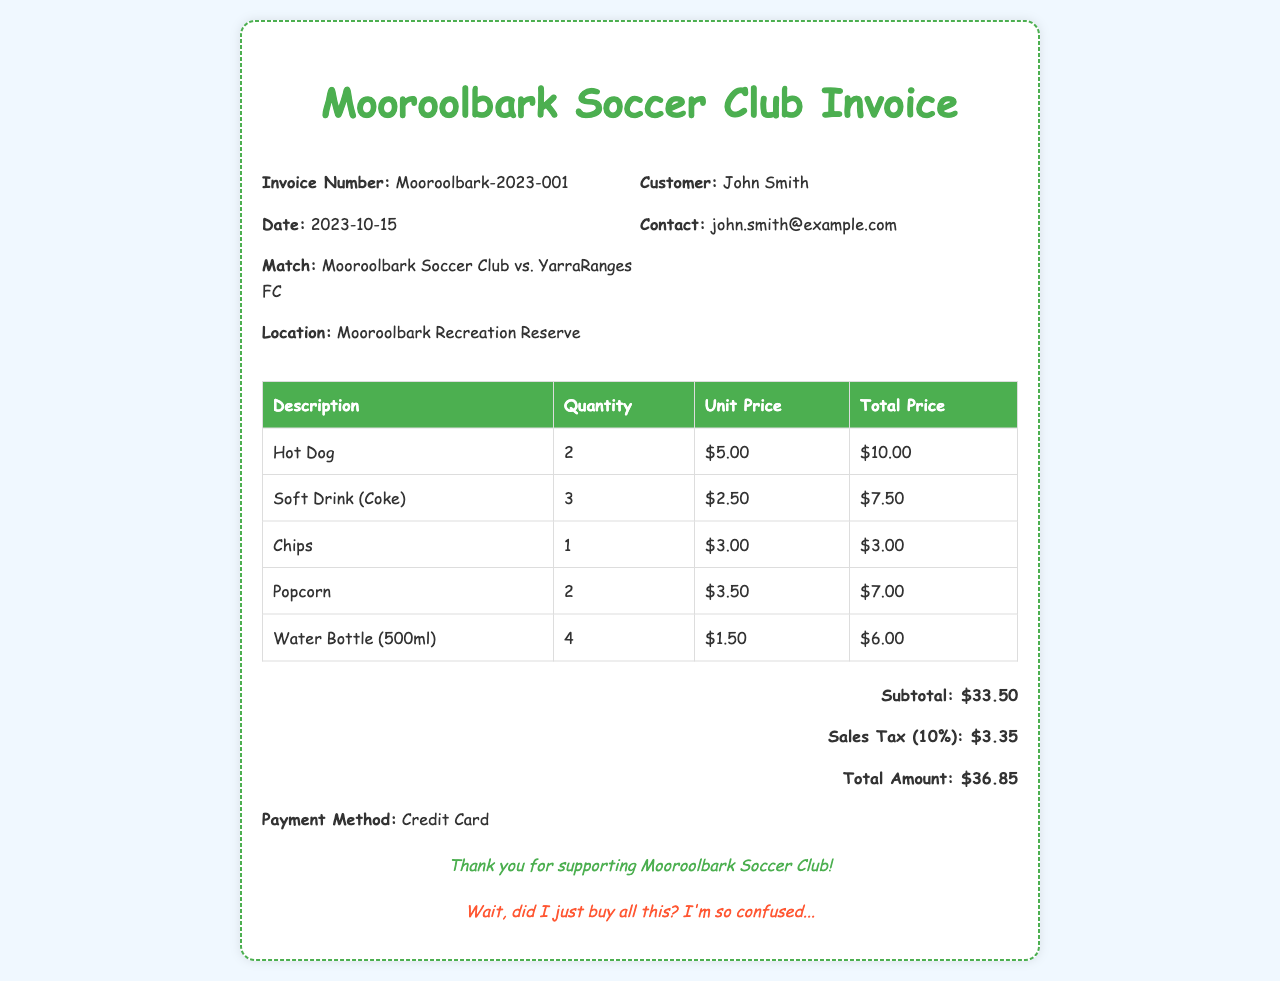What is the invoice number? The invoice number is mentioned at the top of the document under the header section.
Answer: Mooroolbark-2023-001 What is the date of the invoice? The date of the invoice is specified right next to the invoice number in the header section.
Answer: 2023-10-15 Who is the customer? The customer's name is provided in the header section of the document.
Answer: John Smith What match is this invoice related to? The match details are provided in the header section alongside the invoice date.
Answer: Mooroolbark Soccer Club vs. YarraRanges FC What is the subtotal amount? The subtotal amount is found at the bottom of the invoice, detailing the total before tax.
Answer: $33.50 How much sales tax is included? The sales tax amount is listed directly below the subtotal in the invoice totals section.
Answer: $3.35 What is the total amount due? The total amount due is calculated by adding the subtotal and the sales tax, provided at the bottom of the invoice.
Answer: $36.85 How many water bottles were purchased? The quantity of water bottles is found in the food and beverage purchases table.
Answer: 4 What payment method was used? The payment method is indicated towards the end of the invoice after the totals.
Answer: Credit Card What food item had the highest quantity? Analyzing the quantities in the food and beverage purchases table shows which item has the highest amount.
Answer: Soft Drink (Coke) 